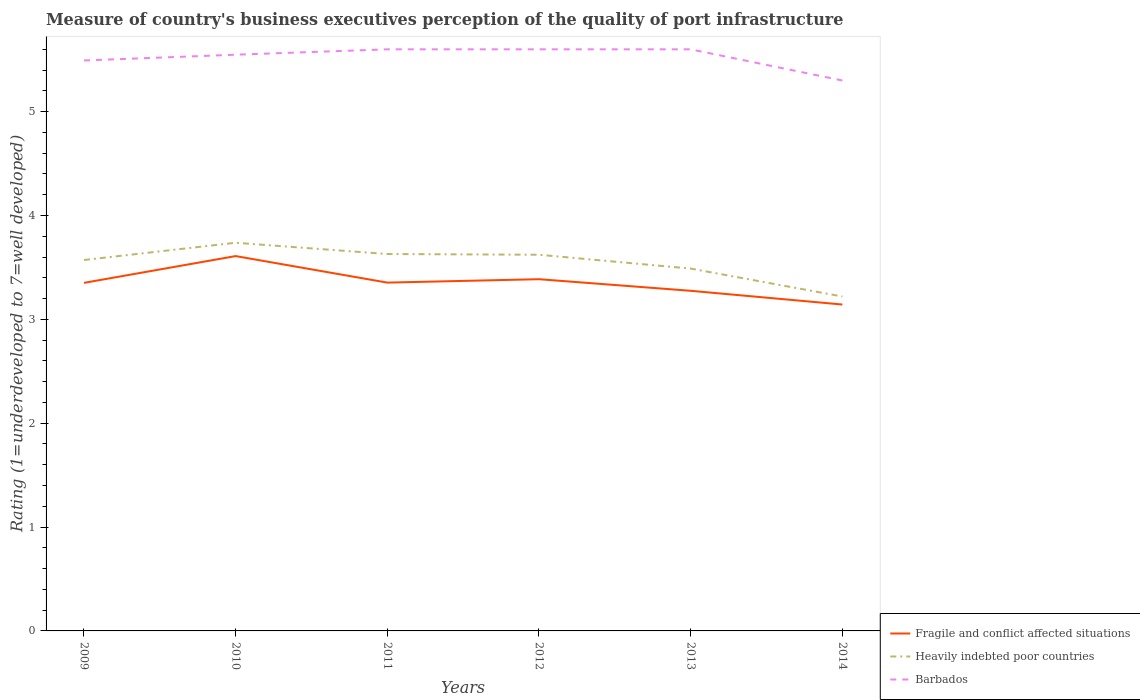Does the line corresponding to Heavily indebted poor countries intersect with the line corresponding to Barbados?
Ensure brevity in your answer.  No. In which year was the ratings of the quality of port infrastructure in Heavily indebted poor countries maximum?
Provide a succinct answer. 2014. What is the total ratings of the quality of port infrastructure in Barbados in the graph?
Provide a short and direct response. 0. What is the difference between the highest and the second highest ratings of the quality of port infrastructure in Barbados?
Your answer should be very brief. 0.3. What is the difference between the highest and the lowest ratings of the quality of port infrastructure in Barbados?
Your answer should be very brief. 4. How many lines are there?
Ensure brevity in your answer.  3. How many years are there in the graph?
Your answer should be compact. 6. What is the difference between two consecutive major ticks on the Y-axis?
Your answer should be very brief. 1. Are the values on the major ticks of Y-axis written in scientific E-notation?
Ensure brevity in your answer.  No. Does the graph contain any zero values?
Your answer should be compact. No. Does the graph contain grids?
Your answer should be very brief. No. Where does the legend appear in the graph?
Provide a succinct answer. Bottom right. How are the legend labels stacked?
Offer a terse response. Vertical. What is the title of the graph?
Your answer should be very brief. Measure of country's business executives perception of the quality of port infrastructure. What is the label or title of the Y-axis?
Your answer should be compact. Rating (1=underdeveloped to 7=well developed). What is the Rating (1=underdeveloped to 7=well developed) of Fragile and conflict affected situations in 2009?
Give a very brief answer. 3.35. What is the Rating (1=underdeveloped to 7=well developed) in Heavily indebted poor countries in 2009?
Keep it short and to the point. 3.57. What is the Rating (1=underdeveloped to 7=well developed) in Barbados in 2009?
Give a very brief answer. 5.49. What is the Rating (1=underdeveloped to 7=well developed) of Fragile and conflict affected situations in 2010?
Give a very brief answer. 3.61. What is the Rating (1=underdeveloped to 7=well developed) of Heavily indebted poor countries in 2010?
Offer a terse response. 3.74. What is the Rating (1=underdeveloped to 7=well developed) in Barbados in 2010?
Ensure brevity in your answer.  5.55. What is the Rating (1=underdeveloped to 7=well developed) of Fragile and conflict affected situations in 2011?
Offer a very short reply. 3.35. What is the Rating (1=underdeveloped to 7=well developed) of Heavily indebted poor countries in 2011?
Provide a short and direct response. 3.63. What is the Rating (1=underdeveloped to 7=well developed) in Barbados in 2011?
Provide a succinct answer. 5.6. What is the Rating (1=underdeveloped to 7=well developed) of Fragile and conflict affected situations in 2012?
Your answer should be very brief. 3.39. What is the Rating (1=underdeveloped to 7=well developed) in Heavily indebted poor countries in 2012?
Provide a succinct answer. 3.62. What is the Rating (1=underdeveloped to 7=well developed) of Fragile and conflict affected situations in 2013?
Offer a very short reply. 3.27. What is the Rating (1=underdeveloped to 7=well developed) of Heavily indebted poor countries in 2013?
Keep it short and to the point. 3.49. What is the Rating (1=underdeveloped to 7=well developed) of Fragile and conflict affected situations in 2014?
Offer a terse response. 3.14. What is the Rating (1=underdeveloped to 7=well developed) in Heavily indebted poor countries in 2014?
Your answer should be very brief. 3.22. What is the Rating (1=underdeveloped to 7=well developed) in Barbados in 2014?
Offer a very short reply. 5.3. Across all years, what is the maximum Rating (1=underdeveloped to 7=well developed) in Fragile and conflict affected situations?
Offer a terse response. 3.61. Across all years, what is the maximum Rating (1=underdeveloped to 7=well developed) of Heavily indebted poor countries?
Give a very brief answer. 3.74. Across all years, what is the minimum Rating (1=underdeveloped to 7=well developed) in Fragile and conflict affected situations?
Your answer should be very brief. 3.14. Across all years, what is the minimum Rating (1=underdeveloped to 7=well developed) in Heavily indebted poor countries?
Ensure brevity in your answer.  3.22. What is the total Rating (1=underdeveloped to 7=well developed) of Fragile and conflict affected situations in the graph?
Your response must be concise. 20.12. What is the total Rating (1=underdeveloped to 7=well developed) in Heavily indebted poor countries in the graph?
Your answer should be compact. 21.27. What is the total Rating (1=underdeveloped to 7=well developed) in Barbados in the graph?
Your answer should be very brief. 33.14. What is the difference between the Rating (1=underdeveloped to 7=well developed) of Fragile and conflict affected situations in 2009 and that in 2010?
Provide a succinct answer. -0.26. What is the difference between the Rating (1=underdeveloped to 7=well developed) of Heavily indebted poor countries in 2009 and that in 2010?
Provide a succinct answer. -0.17. What is the difference between the Rating (1=underdeveloped to 7=well developed) of Barbados in 2009 and that in 2010?
Provide a short and direct response. -0.06. What is the difference between the Rating (1=underdeveloped to 7=well developed) in Fragile and conflict affected situations in 2009 and that in 2011?
Your answer should be compact. -0. What is the difference between the Rating (1=underdeveloped to 7=well developed) of Heavily indebted poor countries in 2009 and that in 2011?
Offer a terse response. -0.06. What is the difference between the Rating (1=underdeveloped to 7=well developed) of Barbados in 2009 and that in 2011?
Provide a short and direct response. -0.11. What is the difference between the Rating (1=underdeveloped to 7=well developed) in Fragile and conflict affected situations in 2009 and that in 2012?
Give a very brief answer. -0.04. What is the difference between the Rating (1=underdeveloped to 7=well developed) of Heavily indebted poor countries in 2009 and that in 2012?
Keep it short and to the point. -0.05. What is the difference between the Rating (1=underdeveloped to 7=well developed) of Barbados in 2009 and that in 2012?
Your answer should be very brief. -0.11. What is the difference between the Rating (1=underdeveloped to 7=well developed) in Fragile and conflict affected situations in 2009 and that in 2013?
Provide a succinct answer. 0.08. What is the difference between the Rating (1=underdeveloped to 7=well developed) of Heavily indebted poor countries in 2009 and that in 2013?
Your response must be concise. 0.08. What is the difference between the Rating (1=underdeveloped to 7=well developed) in Barbados in 2009 and that in 2013?
Ensure brevity in your answer.  -0.11. What is the difference between the Rating (1=underdeveloped to 7=well developed) of Fragile and conflict affected situations in 2009 and that in 2014?
Offer a very short reply. 0.21. What is the difference between the Rating (1=underdeveloped to 7=well developed) of Heavily indebted poor countries in 2009 and that in 2014?
Provide a succinct answer. 0.35. What is the difference between the Rating (1=underdeveloped to 7=well developed) of Barbados in 2009 and that in 2014?
Make the answer very short. 0.19. What is the difference between the Rating (1=underdeveloped to 7=well developed) in Fragile and conflict affected situations in 2010 and that in 2011?
Offer a terse response. 0.26. What is the difference between the Rating (1=underdeveloped to 7=well developed) of Heavily indebted poor countries in 2010 and that in 2011?
Make the answer very short. 0.11. What is the difference between the Rating (1=underdeveloped to 7=well developed) of Barbados in 2010 and that in 2011?
Offer a terse response. -0.05. What is the difference between the Rating (1=underdeveloped to 7=well developed) in Fragile and conflict affected situations in 2010 and that in 2012?
Provide a succinct answer. 0.22. What is the difference between the Rating (1=underdeveloped to 7=well developed) in Heavily indebted poor countries in 2010 and that in 2012?
Make the answer very short. 0.12. What is the difference between the Rating (1=underdeveloped to 7=well developed) of Barbados in 2010 and that in 2012?
Offer a very short reply. -0.05. What is the difference between the Rating (1=underdeveloped to 7=well developed) in Fragile and conflict affected situations in 2010 and that in 2013?
Your answer should be very brief. 0.33. What is the difference between the Rating (1=underdeveloped to 7=well developed) of Heavily indebted poor countries in 2010 and that in 2013?
Your answer should be compact. 0.25. What is the difference between the Rating (1=underdeveloped to 7=well developed) of Barbados in 2010 and that in 2013?
Your answer should be very brief. -0.05. What is the difference between the Rating (1=underdeveloped to 7=well developed) of Fragile and conflict affected situations in 2010 and that in 2014?
Provide a succinct answer. 0.47. What is the difference between the Rating (1=underdeveloped to 7=well developed) in Heavily indebted poor countries in 2010 and that in 2014?
Provide a succinct answer. 0.52. What is the difference between the Rating (1=underdeveloped to 7=well developed) of Barbados in 2010 and that in 2014?
Provide a succinct answer. 0.25. What is the difference between the Rating (1=underdeveloped to 7=well developed) of Fragile and conflict affected situations in 2011 and that in 2012?
Keep it short and to the point. -0.03. What is the difference between the Rating (1=underdeveloped to 7=well developed) in Heavily indebted poor countries in 2011 and that in 2012?
Ensure brevity in your answer.  0.01. What is the difference between the Rating (1=underdeveloped to 7=well developed) of Barbados in 2011 and that in 2012?
Your answer should be compact. 0. What is the difference between the Rating (1=underdeveloped to 7=well developed) of Fragile and conflict affected situations in 2011 and that in 2013?
Offer a very short reply. 0.08. What is the difference between the Rating (1=underdeveloped to 7=well developed) of Heavily indebted poor countries in 2011 and that in 2013?
Offer a terse response. 0.14. What is the difference between the Rating (1=underdeveloped to 7=well developed) in Barbados in 2011 and that in 2013?
Keep it short and to the point. 0. What is the difference between the Rating (1=underdeveloped to 7=well developed) of Fragile and conflict affected situations in 2011 and that in 2014?
Ensure brevity in your answer.  0.21. What is the difference between the Rating (1=underdeveloped to 7=well developed) in Heavily indebted poor countries in 2011 and that in 2014?
Offer a very short reply. 0.41. What is the difference between the Rating (1=underdeveloped to 7=well developed) of Barbados in 2011 and that in 2014?
Keep it short and to the point. 0.3. What is the difference between the Rating (1=underdeveloped to 7=well developed) in Fragile and conflict affected situations in 2012 and that in 2013?
Give a very brief answer. 0.11. What is the difference between the Rating (1=underdeveloped to 7=well developed) of Heavily indebted poor countries in 2012 and that in 2013?
Your answer should be compact. 0.13. What is the difference between the Rating (1=underdeveloped to 7=well developed) of Fragile and conflict affected situations in 2012 and that in 2014?
Your answer should be compact. 0.24. What is the difference between the Rating (1=underdeveloped to 7=well developed) in Heavily indebted poor countries in 2012 and that in 2014?
Your answer should be compact. 0.4. What is the difference between the Rating (1=underdeveloped to 7=well developed) of Barbados in 2012 and that in 2014?
Provide a short and direct response. 0.3. What is the difference between the Rating (1=underdeveloped to 7=well developed) of Fragile and conflict affected situations in 2013 and that in 2014?
Offer a terse response. 0.13. What is the difference between the Rating (1=underdeveloped to 7=well developed) of Heavily indebted poor countries in 2013 and that in 2014?
Provide a short and direct response. 0.27. What is the difference between the Rating (1=underdeveloped to 7=well developed) in Fragile and conflict affected situations in 2009 and the Rating (1=underdeveloped to 7=well developed) in Heavily indebted poor countries in 2010?
Keep it short and to the point. -0.39. What is the difference between the Rating (1=underdeveloped to 7=well developed) in Fragile and conflict affected situations in 2009 and the Rating (1=underdeveloped to 7=well developed) in Barbados in 2010?
Ensure brevity in your answer.  -2.2. What is the difference between the Rating (1=underdeveloped to 7=well developed) in Heavily indebted poor countries in 2009 and the Rating (1=underdeveloped to 7=well developed) in Barbados in 2010?
Give a very brief answer. -1.98. What is the difference between the Rating (1=underdeveloped to 7=well developed) in Fragile and conflict affected situations in 2009 and the Rating (1=underdeveloped to 7=well developed) in Heavily indebted poor countries in 2011?
Your response must be concise. -0.28. What is the difference between the Rating (1=underdeveloped to 7=well developed) in Fragile and conflict affected situations in 2009 and the Rating (1=underdeveloped to 7=well developed) in Barbados in 2011?
Ensure brevity in your answer.  -2.25. What is the difference between the Rating (1=underdeveloped to 7=well developed) in Heavily indebted poor countries in 2009 and the Rating (1=underdeveloped to 7=well developed) in Barbados in 2011?
Your response must be concise. -2.03. What is the difference between the Rating (1=underdeveloped to 7=well developed) of Fragile and conflict affected situations in 2009 and the Rating (1=underdeveloped to 7=well developed) of Heavily indebted poor countries in 2012?
Make the answer very short. -0.27. What is the difference between the Rating (1=underdeveloped to 7=well developed) in Fragile and conflict affected situations in 2009 and the Rating (1=underdeveloped to 7=well developed) in Barbados in 2012?
Provide a succinct answer. -2.25. What is the difference between the Rating (1=underdeveloped to 7=well developed) of Heavily indebted poor countries in 2009 and the Rating (1=underdeveloped to 7=well developed) of Barbados in 2012?
Offer a very short reply. -2.03. What is the difference between the Rating (1=underdeveloped to 7=well developed) of Fragile and conflict affected situations in 2009 and the Rating (1=underdeveloped to 7=well developed) of Heavily indebted poor countries in 2013?
Make the answer very short. -0.14. What is the difference between the Rating (1=underdeveloped to 7=well developed) of Fragile and conflict affected situations in 2009 and the Rating (1=underdeveloped to 7=well developed) of Barbados in 2013?
Ensure brevity in your answer.  -2.25. What is the difference between the Rating (1=underdeveloped to 7=well developed) in Heavily indebted poor countries in 2009 and the Rating (1=underdeveloped to 7=well developed) in Barbados in 2013?
Provide a short and direct response. -2.03. What is the difference between the Rating (1=underdeveloped to 7=well developed) of Fragile and conflict affected situations in 2009 and the Rating (1=underdeveloped to 7=well developed) of Heavily indebted poor countries in 2014?
Give a very brief answer. 0.13. What is the difference between the Rating (1=underdeveloped to 7=well developed) of Fragile and conflict affected situations in 2009 and the Rating (1=underdeveloped to 7=well developed) of Barbados in 2014?
Offer a very short reply. -1.95. What is the difference between the Rating (1=underdeveloped to 7=well developed) in Heavily indebted poor countries in 2009 and the Rating (1=underdeveloped to 7=well developed) in Barbados in 2014?
Give a very brief answer. -1.73. What is the difference between the Rating (1=underdeveloped to 7=well developed) in Fragile and conflict affected situations in 2010 and the Rating (1=underdeveloped to 7=well developed) in Heavily indebted poor countries in 2011?
Make the answer very short. -0.02. What is the difference between the Rating (1=underdeveloped to 7=well developed) of Fragile and conflict affected situations in 2010 and the Rating (1=underdeveloped to 7=well developed) of Barbados in 2011?
Provide a short and direct response. -1.99. What is the difference between the Rating (1=underdeveloped to 7=well developed) of Heavily indebted poor countries in 2010 and the Rating (1=underdeveloped to 7=well developed) of Barbados in 2011?
Your answer should be very brief. -1.86. What is the difference between the Rating (1=underdeveloped to 7=well developed) in Fragile and conflict affected situations in 2010 and the Rating (1=underdeveloped to 7=well developed) in Heavily indebted poor countries in 2012?
Offer a terse response. -0.01. What is the difference between the Rating (1=underdeveloped to 7=well developed) in Fragile and conflict affected situations in 2010 and the Rating (1=underdeveloped to 7=well developed) in Barbados in 2012?
Give a very brief answer. -1.99. What is the difference between the Rating (1=underdeveloped to 7=well developed) in Heavily indebted poor countries in 2010 and the Rating (1=underdeveloped to 7=well developed) in Barbados in 2012?
Provide a short and direct response. -1.86. What is the difference between the Rating (1=underdeveloped to 7=well developed) in Fragile and conflict affected situations in 2010 and the Rating (1=underdeveloped to 7=well developed) in Heavily indebted poor countries in 2013?
Your answer should be very brief. 0.12. What is the difference between the Rating (1=underdeveloped to 7=well developed) in Fragile and conflict affected situations in 2010 and the Rating (1=underdeveloped to 7=well developed) in Barbados in 2013?
Offer a very short reply. -1.99. What is the difference between the Rating (1=underdeveloped to 7=well developed) of Heavily indebted poor countries in 2010 and the Rating (1=underdeveloped to 7=well developed) of Barbados in 2013?
Make the answer very short. -1.86. What is the difference between the Rating (1=underdeveloped to 7=well developed) of Fragile and conflict affected situations in 2010 and the Rating (1=underdeveloped to 7=well developed) of Heavily indebted poor countries in 2014?
Your answer should be compact. 0.39. What is the difference between the Rating (1=underdeveloped to 7=well developed) in Fragile and conflict affected situations in 2010 and the Rating (1=underdeveloped to 7=well developed) in Barbados in 2014?
Provide a short and direct response. -1.69. What is the difference between the Rating (1=underdeveloped to 7=well developed) in Heavily indebted poor countries in 2010 and the Rating (1=underdeveloped to 7=well developed) in Barbados in 2014?
Offer a terse response. -1.56. What is the difference between the Rating (1=underdeveloped to 7=well developed) in Fragile and conflict affected situations in 2011 and the Rating (1=underdeveloped to 7=well developed) in Heavily indebted poor countries in 2012?
Your answer should be compact. -0.27. What is the difference between the Rating (1=underdeveloped to 7=well developed) of Fragile and conflict affected situations in 2011 and the Rating (1=underdeveloped to 7=well developed) of Barbados in 2012?
Offer a very short reply. -2.25. What is the difference between the Rating (1=underdeveloped to 7=well developed) in Heavily indebted poor countries in 2011 and the Rating (1=underdeveloped to 7=well developed) in Barbados in 2012?
Provide a succinct answer. -1.97. What is the difference between the Rating (1=underdeveloped to 7=well developed) in Fragile and conflict affected situations in 2011 and the Rating (1=underdeveloped to 7=well developed) in Heavily indebted poor countries in 2013?
Provide a short and direct response. -0.14. What is the difference between the Rating (1=underdeveloped to 7=well developed) in Fragile and conflict affected situations in 2011 and the Rating (1=underdeveloped to 7=well developed) in Barbados in 2013?
Provide a succinct answer. -2.25. What is the difference between the Rating (1=underdeveloped to 7=well developed) of Heavily indebted poor countries in 2011 and the Rating (1=underdeveloped to 7=well developed) of Barbados in 2013?
Your response must be concise. -1.97. What is the difference between the Rating (1=underdeveloped to 7=well developed) of Fragile and conflict affected situations in 2011 and the Rating (1=underdeveloped to 7=well developed) of Heavily indebted poor countries in 2014?
Your response must be concise. 0.13. What is the difference between the Rating (1=underdeveloped to 7=well developed) in Fragile and conflict affected situations in 2011 and the Rating (1=underdeveloped to 7=well developed) in Barbados in 2014?
Give a very brief answer. -1.95. What is the difference between the Rating (1=underdeveloped to 7=well developed) in Heavily indebted poor countries in 2011 and the Rating (1=underdeveloped to 7=well developed) in Barbados in 2014?
Provide a short and direct response. -1.67. What is the difference between the Rating (1=underdeveloped to 7=well developed) in Fragile and conflict affected situations in 2012 and the Rating (1=underdeveloped to 7=well developed) in Heavily indebted poor countries in 2013?
Provide a succinct answer. -0.1. What is the difference between the Rating (1=underdeveloped to 7=well developed) in Fragile and conflict affected situations in 2012 and the Rating (1=underdeveloped to 7=well developed) in Barbados in 2013?
Your answer should be compact. -2.21. What is the difference between the Rating (1=underdeveloped to 7=well developed) in Heavily indebted poor countries in 2012 and the Rating (1=underdeveloped to 7=well developed) in Barbados in 2013?
Provide a succinct answer. -1.98. What is the difference between the Rating (1=underdeveloped to 7=well developed) in Fragile and conflict affected situations in 2012 and the Rating (1=underdeveloped to 7=well developed) in Barbados in 2014?
Keep it short and to the point. -1.91. What is the difference between the Rating (1=underdeveloped to 7=well developed) in Heavily indebted poor countries in 2012 and the Rating (1=underdeveloped to 7=well developed) in Barbados in 2014?
Your answer should be very brief. -1.68. What is the difference between the Rating (1=underdeveloped to 7=well developed) in Fragile and conflict affected situations in 2013 and the Rating (1=underdeveloped to 7=well developed) in Heavily indebted poor countries in 2014?
Provide a succinct answer. 0.06. What is the difference between the Rating (1=underdeveloped to 7=well developed) of Fragile and conflict affected situations in 2013 and the Rating (1=underdeveloped to 7=well developed) of Barbados in 2014?
Your answer should be compact. -2.02. What is the difference between the Rating (1=underdeveloped to 7=well developed) in Heavily indebted poor countries in 2013 and the Rating (1=underdeveloped to 7=well developed) in Barbados in 2014?
Your response must be concise. -1.81. What is the average Rating (1=underdeveloped to 7=well developed) of Fragile and conflict affected situations per year?
Offer a very short reply. 3.35. What is the average Rating (1=underdeveloped to 7=well developed) in Heavily indebted poor countries per year?
Provide a short and direct response. 3.54. What is the average Rating (1=underdeveloped to 7=well developed) of Barbados per year?
Offer a terse response. 5.52. In the year 2009, what is the difference between the Rating (1=underdeveloped to 7=well developed) of Fragile and conflict affected situations and Rating (1=underdeveloped to 7=well developed) of Heavily indebted poor countries?
Your response must be concise. -0.22. In the year 2009, what is the difference between the Rating (1=underdeveloped to 7=well developed) in Fragile and conflict affected situations and Rating (1=underdeveloped to 7=well developed) in Barbados?
Provide a short and direct response. -2.14. In the year 2009, what is the difference between the Rating (1=underdeveloped to 7=well developed) in Heavily indebted poor countries and Rating (1=underdeveloped to 7=well developed) in Barbados?
Provide a short and direct response. -1.92. In the year 2010, what is the difference between the Rating (1=underdeveloped to 7=well developed) of Fragile and conflict affected situations and Rating (1=underdeveloped to 7=well developed) of Heavily indebted poor countries?
Offer a very short reply. -0.13. In the year 2010, what is the difference between the Rating (1=underdeveloped to 7=well developed) of Fragile and conflict affected situations and Rating (1=underdeveloped to 7=well developed) of Barbados?
Give a very brief answer. -1.94. In the year 2010, what is the difference between the Rating (1=underdeveloped to 7=well developed) of Heavily indebted poor countries and Rating (1=underdeveloped to 7=well developed) of Barbados?
Your answer should be compact. -1.81. In the year 2011, what is the difference between the Rating (1=underdeveloped to 7=well developed) of Fragile and conflict affected situations and Rating (1=underdeveloped to 7=well developed) of Heavily indebted poor countries?
Your response must be concise. -0.28. In the year 2011, what is the difference between the Rating (1=underdeveloped to 7=well developed) of Fragile and conflict affected situations and Rating (1=underdeveloped to 7=well developed) of Barbados?
Provide a succinct answer. -2.25. In the year 2011, what is the difference between the Rating (1=underdeveloped to 7=well developed) in Heavily indebted poor countries and Rating (1=underdeveloped to 7=well developed) in Barbados?
Provide a short and direct response. -1.97. In the year 2012, what is the difference between the Rating (1=underdeveloped to 7=well developed) in Fragile and conflict affected situations and Rating (1=underdeveloped to 7=well developed) in Heavily indebted poor countries?
Give a very brief answer. -0.24. In the year 2012, what is the difference between the Rating (1=underdeveloped to 7=well developed) in Fragile and conflict affected situations and Rating (1=underdeveloped to 7=well developed) in Barbados?
Give a very brief answer. -2.21. In the year 2012, what is the difference between the Rating (1=underdeveloped to 7=well developed) in Heavily indebted poor countries and Rating (1=underdeveloped to 7=well developed) in Barbados?
Give a very brief answer. -1.98. In the year 2013, what is the difference between the Rating (1=underdeveloped to 7=well developed) in Fragile and conflict affected situations and Rating (1=underdeveloped to 7=well developed) in Heavily indebted poor countries?
Keep it short and to the point. -0.21. In the year 2013, what is the difference between the Rating (1=underdeveloped to 7=well developed) in Fragile and conflict affected situations and Rating (1=underdeveloped to 7=well developed) in Barbados?
Offer a very short reply. -2.33. In the year 2013, what is the difference between the Rating (1=underdeveloped to 7=well developed) of Heavily indebted poor countries and Rating (1=underdeveloped to 7=well developed) of Barbados?
Offer a very short reply. -2.11. In the year 2014, what is the difference between the Rating (1=underdeveloped to 7=well developed) in Fragile and conflict affected situations and Rating (1=underdeveloped to 7=well developed) in Heavily indebted poor countries?
Ensure brevity in your answer.  -0.08. In the year 2014, what is the difference between the Rating (1=underdeveloped to 7=well developed) of Fragile and conflict affected situations and Rating (1=underdeveloped to 7=well developed) of Barbados?
Ensure brevity in your answer.  -2.16. In the year 2014, what is the difference between the Rating (1=underdeveloped to 7=well developed) in Heavily indebted poor countries and Rating (1=underdeveloped to 7=well developed) in Barbados?
Give a very brief answer. -2.08. What is the ratio of the Rating (1=underdeveloped to 7=well developed) in Heavily indebted poor countries in 2009 to that in 2010?
Your response must be concise. 0.96. What is the ratio of the Rating (1=underdeveloped to 7=well developed) in Fragile and conflict affected situations in 2009 to that in 2011?
Offer a very short reply. 1. What is the ratio of the Rating (1=underdeveloped to 7=well developed) in Heavily indebted poor countries in 2009 to that in 2011?
Your response must be concise. 0.98. What is the ratio of the Rating (1=underdeveloped to 7=well developed) in Barbados in 2009 to that in 2011?
Offer a terse response. 0.98. What is the ratio of the Rating (1=underdeveloped to 7=well developed) of Heavily indebted poor countries in 2009 to that in 2012?
Provide a short and direct response. 0.99. What is the ratio of the Rating (1=underdeveloped to 7=well developed) in Barbados in 2009 to that in 2012?
Offer a very short reply. 0.98. What is the ratio of the Rating (1=underdeveloped to 7=well developed) of Fragile and conflict affected situations in 2009 to that in 2013?
Make the answer very short. 1.02. What is the ratio of the Rating (1=underdeveloped to 7=well developed) of Heavily indebted poor countries in 2009 to that in 2013?
Your answer should be compact. 1.02. What is the ratio of the Rating (1=underdeveloped to 7=well developed) of Barbados in 2009 to that in 2013?
Your answer should be compact. 0.98. What is the ratio of the Rating (1=underdeveloped to 7=well developed) in Fragile and conflict affected situations in 2009 to that in 2014?
Give a very brief answer. 1.07. What is the ratio of the Rating (1=underdeveloped to 7=well developed) in Heavily indebted poor countries in 2009 to that in 2014?
Make the answer very short. 1.11. What is the ratio of the Rating (1=underdeveloped to 7=well developed) in Barbados in 2009 to that in 2014?
Provide a short and direct response. 1.04. What is the ratio of the Rating (1=underdeveloped to 7=well developed) in Fragile and conflict affected situations in 2010 to that in 2011?
Offer a very short reply. 1.08. What is the ratio of the Rating (1=underdeveloped to 7=well developed) of Heavily indebted poor countries in 2010 to that in 2011?
Ensure brevity in your answer.  1.03. What is the ratio of the Rating (1=underdeveloped to 7=well developed) in Fragile and conflict affected situations in 2010 to that in 2012?
Your answer should be very brief. 1.07. What is the ratio of the Rating (1=underdeveloped to 7=well developed) in Heavily indebted poor countries in 2010 to that in 2012?
Your answer should be compact. 1.03. What is the ratio of the Rating (1=underdeveloped to 7=well developed) of Barbados in 2010 to that in 2012?
Give a very brief answer. 0.99. What is the ratio of the Rating (1=underdeveloped to 7=well developed) in Fragile and conflict affected situations in 2010 to that in 2013?
Make the answer very short. 1.1. What is the ratio of the Rating (1=underdeveloped to 7=well developed) of Heavily indebted poor countries in 2010 to that in 2013?
Give a very brief answer. 1.07. What is the ratio of the Rating (1=underdeveloped to 7=well developed) in Fragile and conflict affected situations in 2010 to that in 2014?
Your answer should be very brief. 1.15. What is the ratio of the Rating (1=underdeveloped to 7=well developed) in Heavily indebted poor countries in 2010 to that in 2014?
Keep it short and to the point. 1.16. What is the ratio of the Rating (1=underdeveloped to 7=well developed) of Barbados in 2010 to that in 2014?
Your answer should be compact. 1.05. What is the ratio of the Rating (1=underdeveloped to 7=well developed) of Fragile and conflict affected situations in 2011 to that in 2012?
Provide a short and direct response. 0.99. What is the ratio of the Rating (1=underdeveloped to 7=well developed) of Barbados in 2011 to that in 2012?
Offer a terse response. 1. What is the ratio of the Rating (1=underdeveloped to 7=well developed) of Fragile and conflict affected situations in 2011 to that in 2013?
Keep it short and to the point. 1.02. What is the ratio of the Rating (1=underdeveloped to 7=well developed) of Heavily indebted poor countries in 2011 to that in 2013?
Offer a very short reply. 1.04. What is the ratio of the Rating (1=underdeveloped to 7=well developed) of Barbados in 2011 to that in 2013?
Provide a short and direct response. 1. What is the ratio of the Rating (1=underdeveloped to 7=well developed) of Fragile and conflict affected situations in 2011 to that in 2014?
Provide a short and direct response. 1.07. What is the ratio of the Rating (1=underdeveloped to 7=well developed) of Heavily indebted poor countries in 2011 to that in 2014?
Give a very brief answer. 1.13. What is the ratio of the Rating (1=underdeveloped to 7=well developed) in Barbados in 2011 to that in 2014?
Your answer should be compact. 1.06. What is the ratio of the Rating (1=underdeveloped to 7=well developed) in Fragile and conflict affected situations in 2012 to that in 2013?
Provide a short and direct response. 1.03. What is the ratio of the Rating (1=underdeveloped to 7=well developed) of Heavily indebted poor countries in 2012 to that in 2013?
Provide a succinct answer. 1.04. What is the ratio of the Rating (1=underdeveloped to 7=well developed) in Barbados in 2012 to that in 2013?
Ensure brevity in your answer.  1. What is the ratio of the Rating (1=underdeveloped to 7=well developed) in Fragile and conflict affected situations in 2012 to that in 2014?
Your response must be concise. 1.08. What is the ratio of the Rating (1=underdeveloped to 7=well developed) of Heavily indebted poor countries in 2012 to that in 2014?
Offer a very short reply. 1.12. What is the ratio of the Rating (1=underdeveloped to 7=well developed) of Barbados in 2012 to that in 2014?
Keep it short and to the point. 1.06. What is the ratio of the Rating (1=underdeveloped to 7=well developed) in Fragile and conflict affected situations in 2013 to that in 2014?
Your answer should be very brief. 1.04. What is the ratio of the Rating (1=underdeveloped to 7=well developed) in Heavily indebted poor countries in 2013 to that in 2014?
Your answer should be very brief. 1.08. What is the ratio of the Rating (1=underdeveloped to 7=well developed) in Barbados in 2013 to that in 2014?
Make the answer very short. 1.06. What is the difference between the highest and the second highest Rating (1=underdeveloped to 7=well developed) in Fragile and conflict affected situations?
Your answer should be very brief. 0.22. What is the difference between the highest and the second highest Rating (1=underdeveloped to 7=well developed) in Heavily indebted poor countries?
Your answer should be compact. 0.11. What is the difference between the highest and the second highest Rating (1=underdeveloped to 7=well developed) of Barbados?
Give a very brief answer. 0. What is the difference between the highest and the lowest Rating (1=underdeveloped to 7=well developed) in Fragile and conflict affected situations?
Provide a succinct answer. 0.47. What is the difference between the highest and the lowest Rating (1=underdeveloped to 7=well developed) in Heavily indebted poor countries?
Your answer should be very brief. 0.52. 